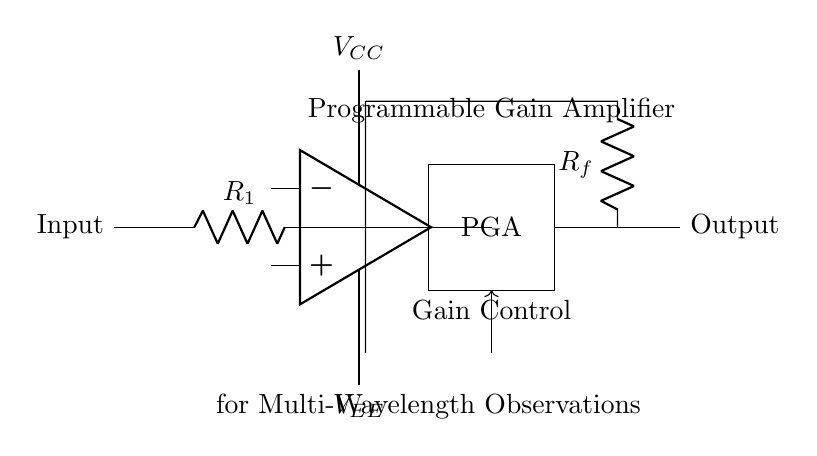What is the role of R1 in this circuit? R1 is a resistor connected in series with the input, which helps to limit the input current and determines the input impedance of the amplifier circuit.
Answer: resistor What type of amplifier is represented in this circuit? The circuit diagram shows a Programmable Gain Amplifier (PGA). This is indicated by the labeled block within the circuit that specifies its functionality.
Answer: Programmable Gain Amplifier How many power supply voltages are indicated in the circuit? There are two power supply voltages indicated: one labeled as VCC and the other labeled as VEE. These supply voltages are essential for the operation of the operational amplifier in the circuit.
Answer: two What does the gain control signal do? The gain control signal allows for the adaptation of the amplifier's gain according to the requirements of the observed signal, which is crucial for multi-wavelength observations to optimize signal processing.
Answer: adapt gain What is connected to the output of the amplifier? The output of the amplifier is connected to a resistor labeled Rf, which typically serves to set the feedback and help determine the overall gain of the amplifier.
Answer: resistor What is the function of the op-amp in this circuit? The operational amplifier (op-amp) amplifies the input signal, and by varying the gain through the PGA, it can adaptively process multi-wavelength signals effectively.
Answer: amplify signal 